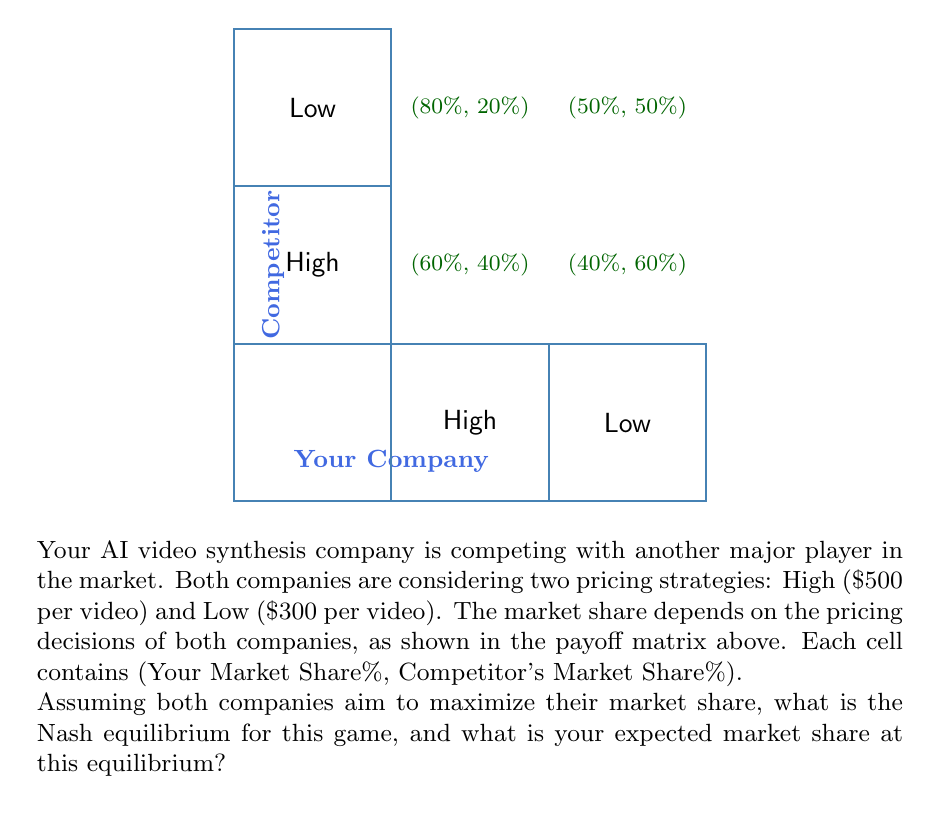Show me your answer to this math problem. To solve this problem, we need to follow these steps:

1. Identify the dominant strategies for each player:
   - For your company:
     * If competitor chooses High: Low (80%) > High (60%)
     * If competitor chooses Low: Low (50%) > High (40%)
     Low is always better, so it's the dominant strategy for your company.
   - For the competitor:
     * If you choose High: Low (60%) > High (40%)
     * If you choose Low: High (50%) > Low (20%)
     There's no dominant strategy for the competitor.

2. Find the Nash equilibrium:
   Since you have a dominant strategy (Low), the competitor's best response to your Low strategy is High (50% > 20%).

3. Determine the equilibrium outcome:
   The Nash equilibrium is (Low, High), meaning you choose Low pricing and the competitor chooses High pricing.

4. Calculate your expected market share:
   At the equilibrium (Low, High), your market share is 80%.

The Nash equilibrium represents a stable state where neither player has an incentive to unilaterally change their strategy. In this case, if you tried to switch to High pricing, your market share would decrease to 60%. Similarly, if the competitor switched to Low pricing, their market share would decrease from 50% to 20%.
Answer: Nash equilibrium: (Low, High); Your market share: 80% 